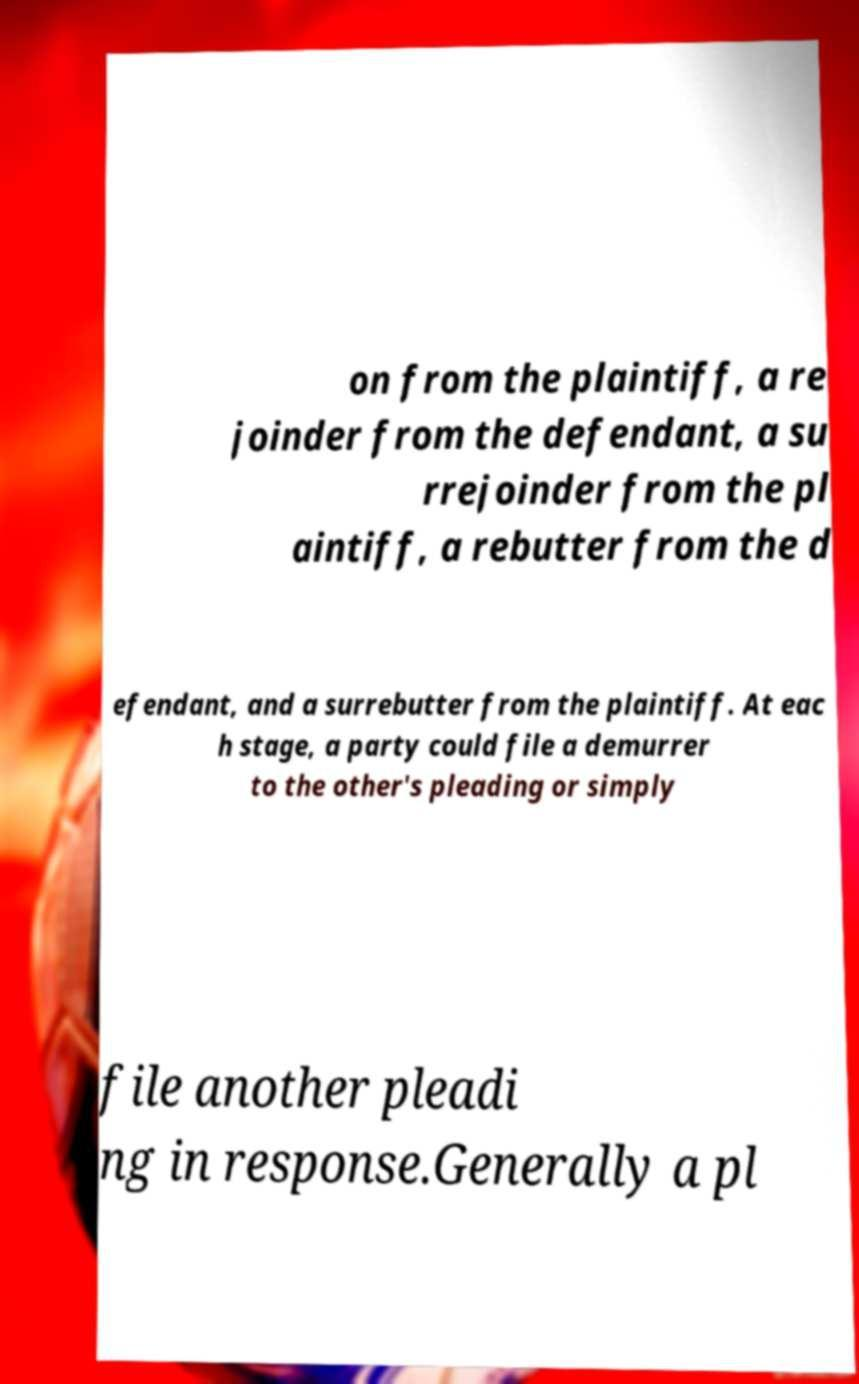Please read and relay the text visible in this image. What does it say? on from the plaintiff, a re joinder from the defendant, a su rrejoinder from the pl aintiff, a rebutter from the d efendant, and a surrebutter from the plaintiff. At eac h stage, a party could file a demurrer to the other's pleading or simply file another pleadi ng in response.Generally a pl 